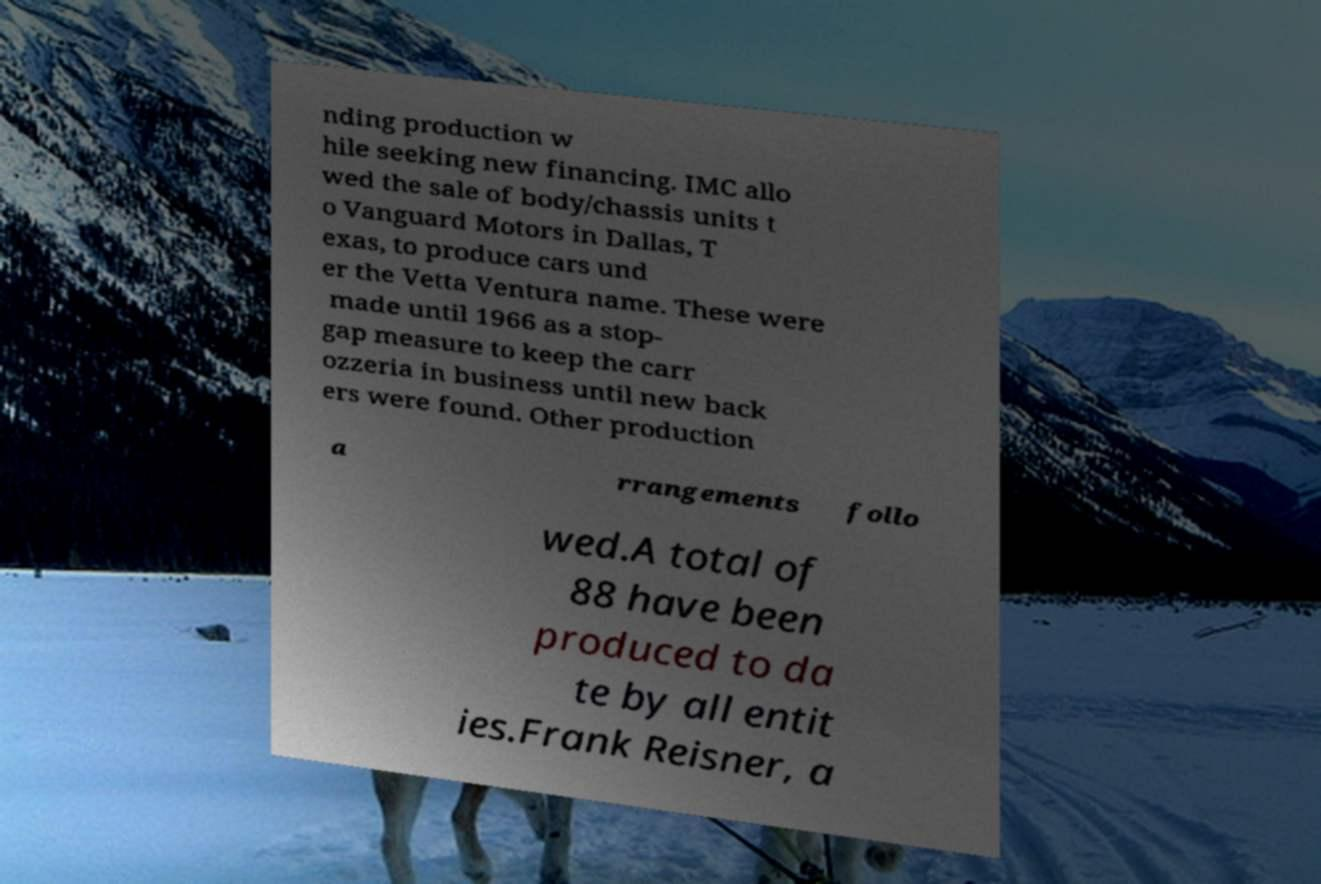Could you assist in decoding the text presented in this image and type it out clearly? nding production w hile seeking new financing. IMC allo wed the sale of body/chassis units t o Vanguard Motors in Dallas, T exas, to produce cars und er the Vetta Ventura name. These were made until 1966 as a stop- gap measure to keep the carr ozzeria in business until new back ers were found. Other production a rrangements follo wed.A total of 88 have been produced to da te by all entit ies.Frank Reisner, a 